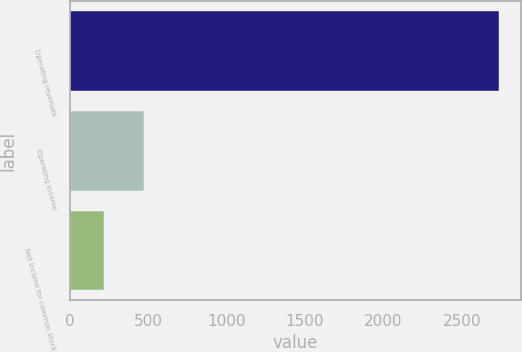<chart> <loc_0><loc_0><loc_500><loc_500><bar_chart><fcel>Operating revenues<fcel>Operating income<fcel>Net income for common stock<nl><fcel>2741<fcel>471.2<fcel>219<nl></chart> 